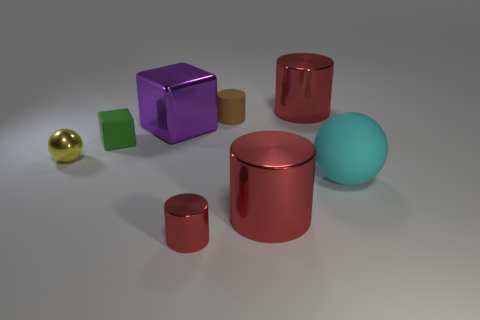Add 1 big cubes. How many objects exist? 9 Subtract all cyan cylinders. Subtract all gray cubes. How many cylinders are left? 4 Subtract all red cubes. How many yellow cylinders are left? 0 Subtract all objects. Subtract all purple matte objects. How many objects are left? 0 Add 7 small spheres. How many small spheres are left? 8 Add 2 tiny green blocks. How many tiny green blocks exist? 3 Subtract all brown cylinders. How many cylinders are left? 3 Subtract all red metal cylinders. How many cylinders are left? 1 Subtract 0 green balls. How many objects are left? 8 Subtract all balls. How many objects are left? 6 